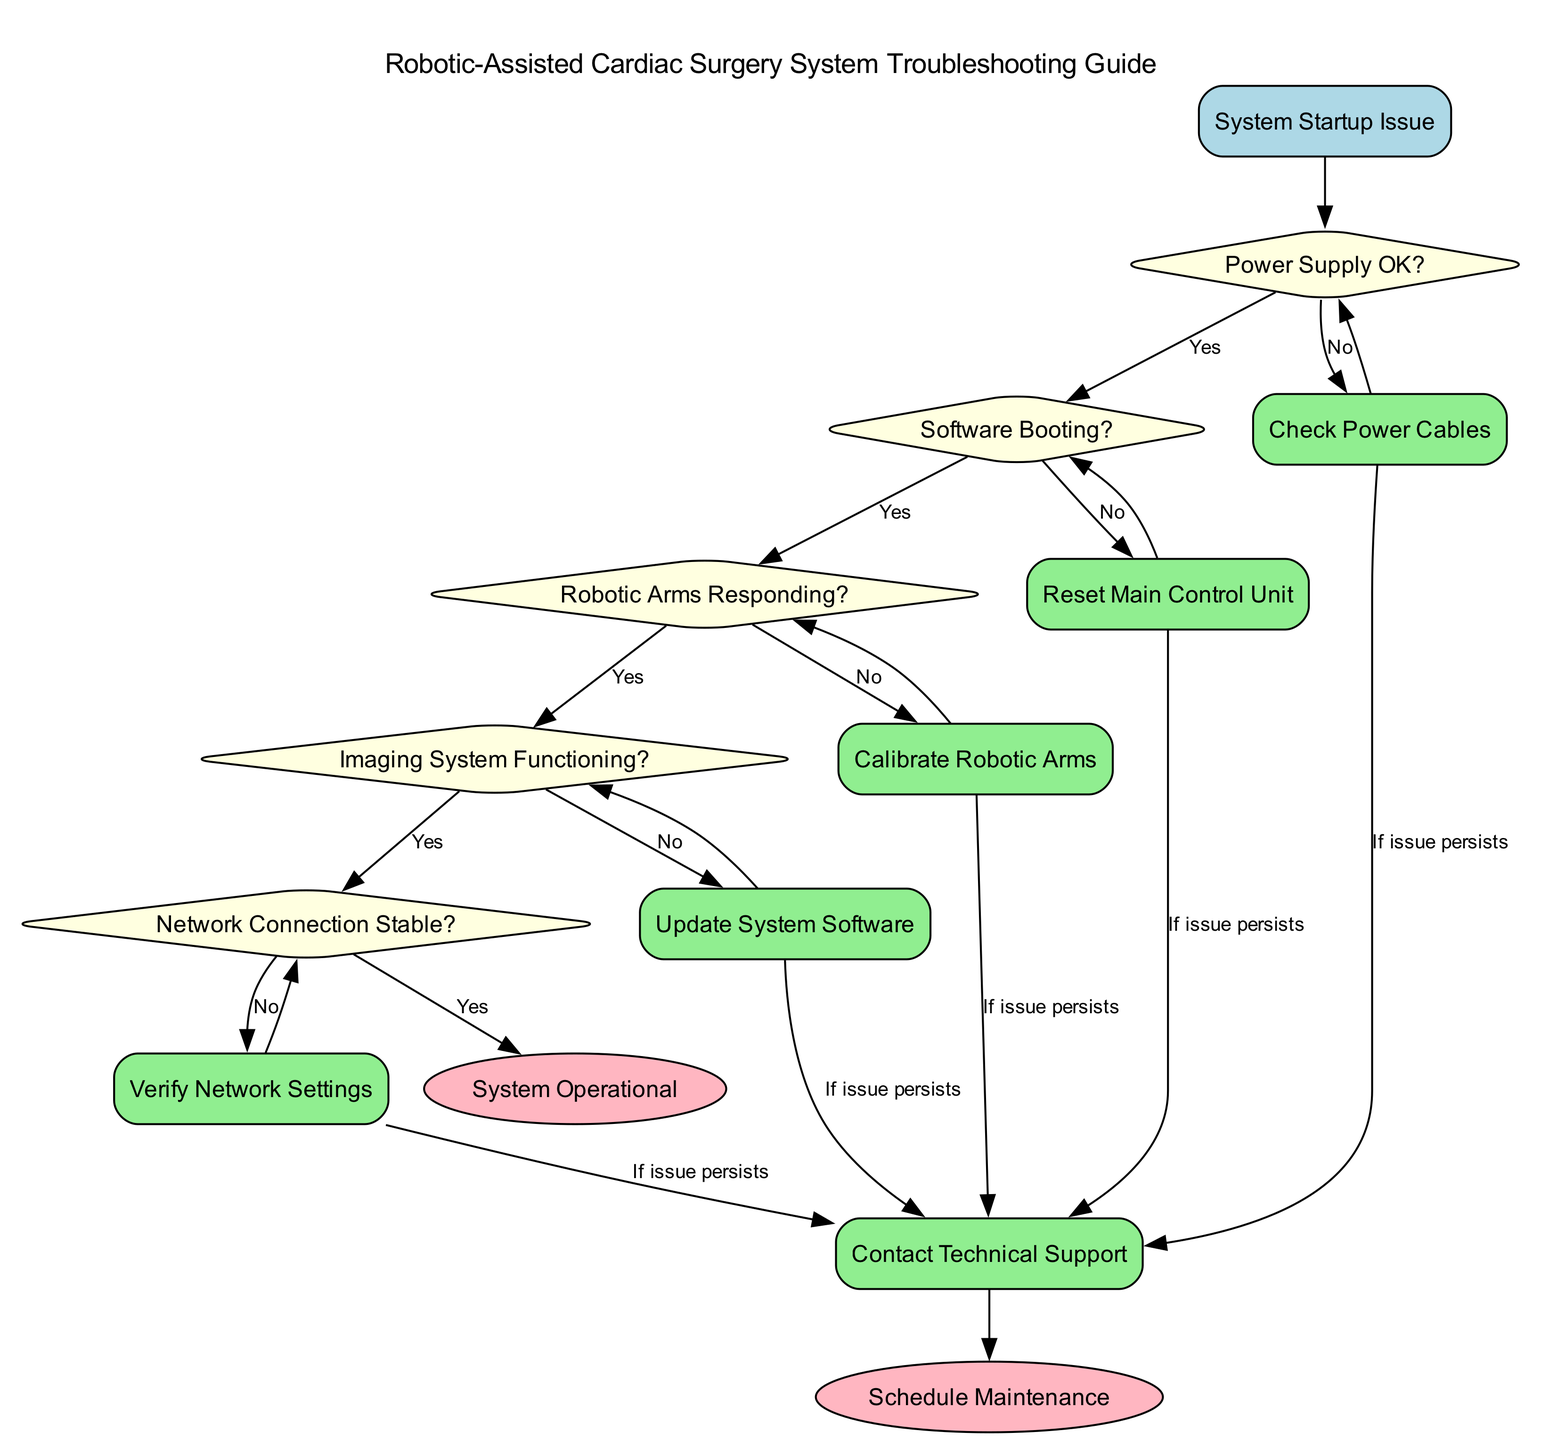What is the first decision node in the diagram? The first decision node is the first point where a choice must be made regarding the system's status. According to the diagram, that node is "Power Supply OK?"
Answer: Power Supply OK? How many action nodes are present in the diagram? The action nodes include "Check Power Cables," "Reset Main Control Unit," "Calibrate Robotic Arms," "Update System Software," "Verify Network Settings," and "Contact Technical Support." Counting these gives a total of six action nodes.
Answer: 6 What action should be taken if the "Power Supply OK?" decision node results in "No"? If the "Power Supply OK?" node indicates "No," the next action to take is "Check Power Cables." This indicates that the system requires checking the power connections first to ensure the power supply is functioning.
Answer: Check Power Cables If the "Imaging System Functioning?" is "No," what is the next action? When the "Imaging System Functioning?" node is answered with "No," the flow indicates that the next action to take is "Update System Software." This means addressing potential software issues that could affect imaging functionalities.
Answer: Update System Software What happens if the "Network Connection Stable?" decision is "No"? If the "Network Connection Stable?" decision is "No," the next action is to "Verify Network Settings." This means that there may be configuration issues in the network that require attention.
Answer: Verify Network Settings Which node leads to "Schedule Maintenance"? The node "Contact Technical Support" leads to "Schedule Maintenance." This means if the troubleshooting actions do not resolve the system issues, maintenance should be scheduled through technical support.
Answer: Contact Technical Support 